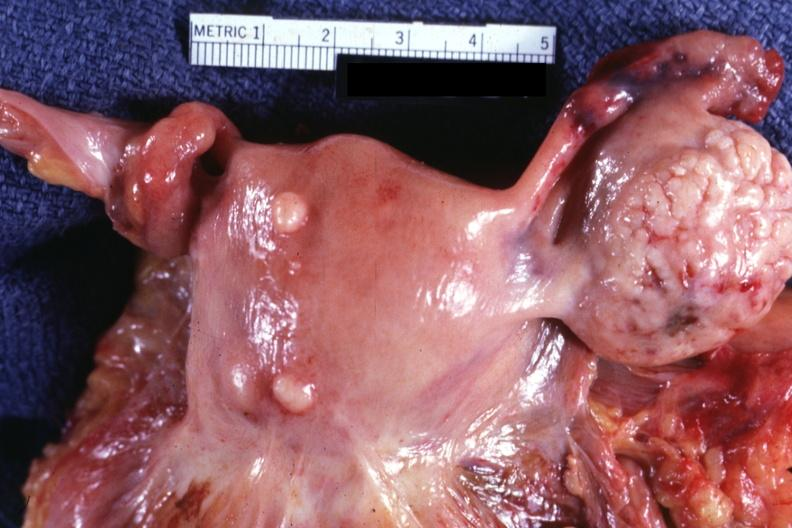does situs inversus show external view of uterus with two small subserosal myomas?
Answer the question using a single word or phrase. No 